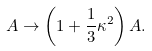Convert formula to latex. <formula><loc_0><loc_0><loc_500><loc_500>A \to \left ( 1 + \frac { 1 } { 3 } \kappa ^ { 2 } \right ) A .</formula> 